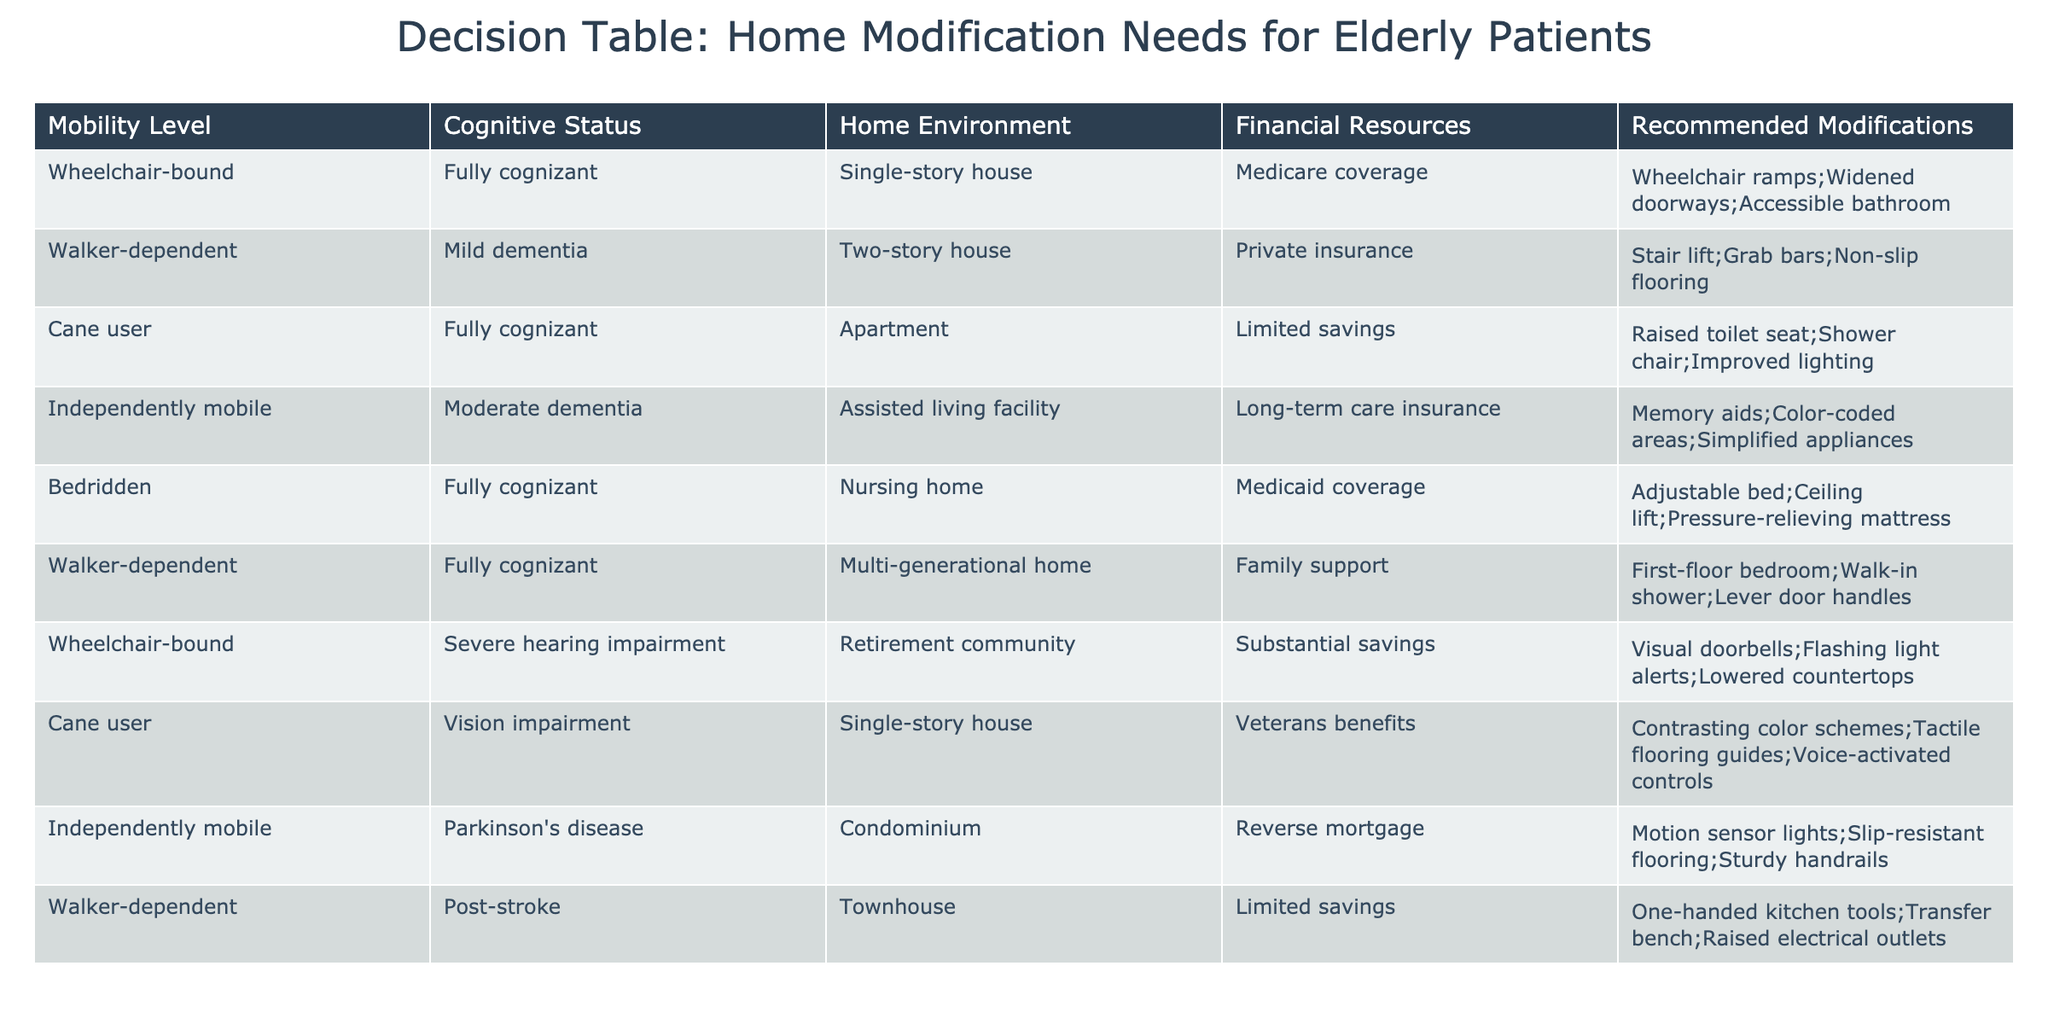What recommendations are made for a wheelchair-bound individual with Medicare coverage? The table shows that for wheelchair-bound individuals with Medicare coverage, the recommended modifications include wheelchair ramps, widened doorways, and an accessible bathroom. This information can be directly retrieved from the "Recommended Modifications" column corresponding to this user's status.
Answer: Wheelchair ramps; widened doorways; accessible bathroom How many patients have been assessed as walker-dependent? By examining the "Mobility Level" column of the table, we can identify three instances of patients categorized as walker-dependent. These are found in rows 2, 6, and 9. Counting these rows gives us a total of three walker-dependent patients.
Answer: 3 Is there a recommendation for individuals with vision impairment living in a single-story house? Yes, the table indicates that for cane users with vision impairment living in a single-story house, the recommended modifications are contrasting color schemes, tactile flooring guides, and voice-activated controls, confirming that there are indeed tailored recommendations for this condition.
Answer: Yes What is the average number of recommended modifications for independently mobile individuals with moderate dementia? The table shows that there is one instance of an independently mobile patient with moderate dementia. Their recommended modifications include memory aids, color-coded areas, and simplified appliances, amounting to three modifications in total. The average, therefore, is 3 since there is only one patient in this category.
Answer: 3 Are adjustable beds recommended for individuals who are bedridden? Yes, adjustable beds are recommended for bedridden individuals, along with other modifications such as a ceiling lift and a pressure-relieving mattress, as indicated in the corresponding row for bedridden patients.
Answer: Yes What modifications are suggested for a walker-dependent patient who has limited savings? The table specifies that for a walker-dependent individual with limited savings, the recommended modifications are one-handed kitchen tools, a transfer bench, and raised electrical outlets. This information can be found by referencing the relevant row where these details are recorded.
Answer: One-handed kitchen tools; transfer bench; raised electrical outlets How many different financial resources are represented in the table? The "Financial Resources" column indicates five distinct types of financial support: Medicare coverage, private insurance, limited savings, long-term care insurance, and Medicaid coverage. Examining the unique entries in this column gives a total of five different financial resources represented.
Answer: 5 What recommendations do individuals with severe hearing impairment receive? The table reveals that for wheelchair-bound individuals with severe hearing impairment, the recommended modifications are visual doorbells, flashing light alerts, and lowered countertops. This can be confirmed by looking up the row designated for individuals with severe hearing impairment.
Answer: Visual doorbells; flashing light alerts; lowered countertops What is the total number of patients who live in a multi-generational home? Reviewing the table shows there is one patient in the multi-generational home category, specifically a walker-dependent individual with family support. This can be verified by scanning through the "Home Environment" column for this designation.
Answer: 1 What modifications are recommended for an independently mobile patient with Parkinson's disease? The table specifies that for an independently mobile individual with Parkinson's disease, the recommended modifications are motion sensor lights, slip-resistant flooring, and sturdy handrails, which can be directly identified in the appropriate row.
Answer: Motion sensor lights; slip-resistant flooring; sturdy handrails 